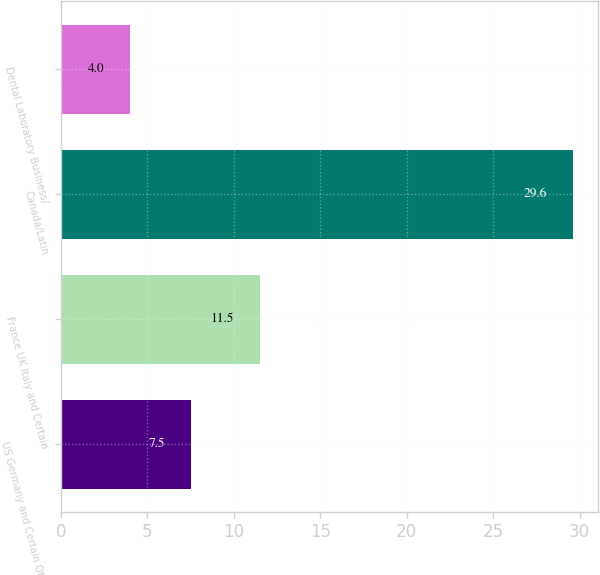<chart> <loc_0><loc_0><loc_500><loc_500><bar_chart><fcel>US Germany and Certain Other<fcel>France UK Italy and Certain<fcel>Canada/Latin<fcel>Dental Laboratory Business/<nl><fcel>7.5<fcel>11.5<fcel>29.6<fcel>4<nl></chart> 